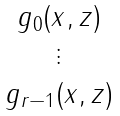<formula> <loc_0><loc_0><loc_500><loc_500>\begin{matrix} g _ { 0 } ( x , z ) \\ \vdots \\ g _ { r - 1 } ( x , z ) \end{matrix}</formula> 